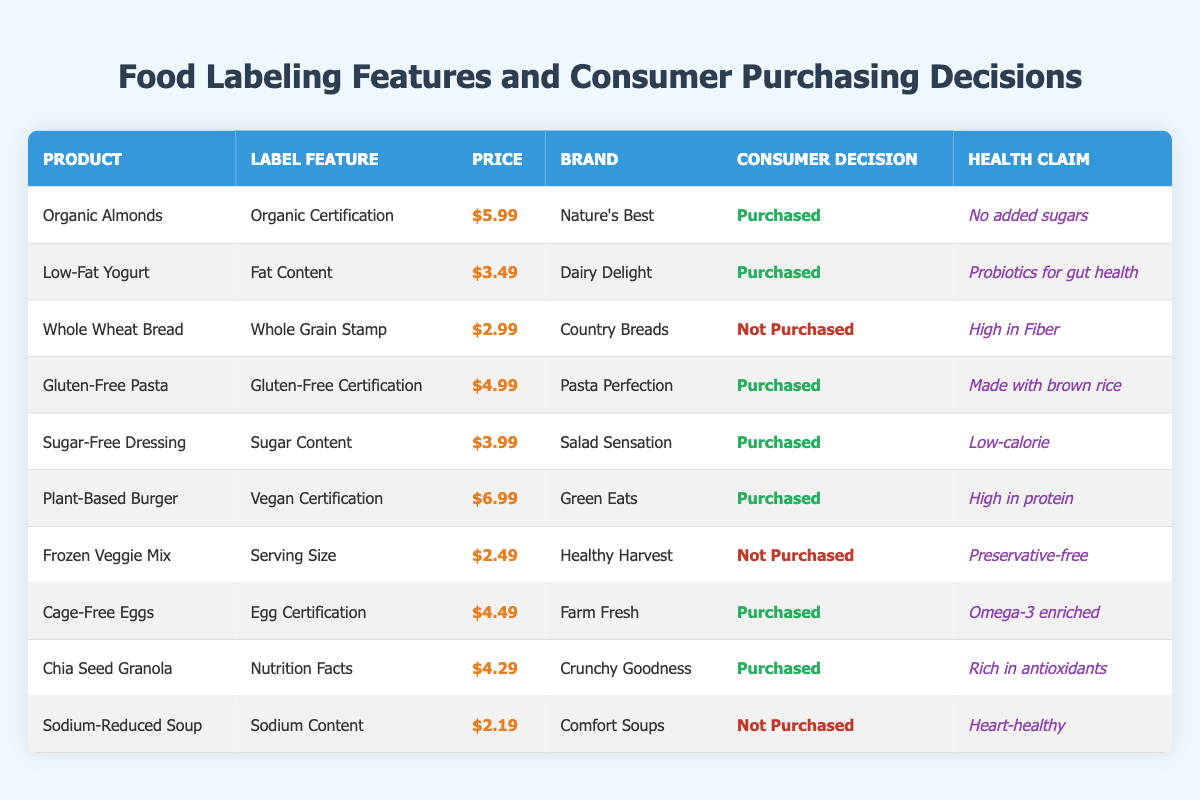What is the price of Organic Almonds? The table lists Organic Almonds, and the corresponding price shown is $5.99.
Answer: $5.99 How many products were purchased in the table? By scanning the "Consumer Decision" column, I count the number of entries marked as "Purchased." There are six products: Organic Almonds, Low-Fat Yogurt, Gluten-Free Pasta, Sugar-Free Dressing, Plant-Based Burger, Cage-Free Eggs, and Chia Seed Granola.
Answer: 6 What is the health claim of the Plant-Based Burger? In the table, I find the row for Plant-Based Burger, which indicates the health claim as "High in protein."
Answer: High in protein Is the Whole Wheat Bread labeled as a health product? Whole Wheat Bread has a health claim stating "High in Fiber." Thus, it can be considered a health product.
Answer: Yes What is the average price of the products that were purchased? The prices for the purchased products are: $5.99, $3.49, $4.99, $3.99, $6.99, and $4.29. Adding them gives $29.74. There are 6 purchased products, so I divide $29.74 by 6 to find the average price: $29.74 / 6 = $4.95667, rounding to $4.96.
Answer: $4.96 What percentage of products with a health claim were purchased? Counting the health claims, we have 10 products total with health claims. Out of these, 6 were purchased. To find the percentage, I calculate (6 / 10) * 100 = 60%.
Answer: 60% Which product had the lowest price and what was it? Scanning the price column, I find that the lowest price is $2.19, corresponding to Sodium-Reduced Soup.
Answer: Sodium-Reduced Soup How many products were not purchased and also had health claims associated with them? Looking at the table, I find two products that were not purchased: Whole Wheat Bread (High in Fiber) and Sodium-Reduced Soup (Heart-healthy). Both have health claims. So, there are two products in this category.
Answer: 2 Are all products with a sugar-related label feature purchased? I check the table for sugar-related products. The only products referring to sugar are Sugar-Free Dressing (Purchased) and Whole Wheat Bread, which is not labeled explicitly as sugar-related but combining this with others, I find that not all are purchased, thus answering 'no.'
Answer: No 